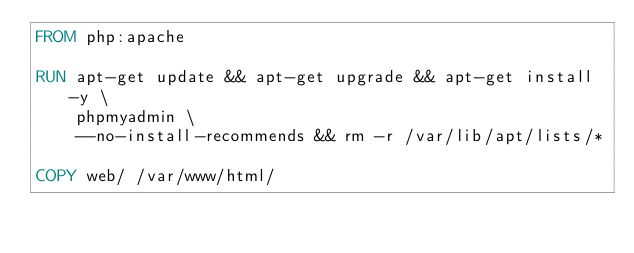<code> <loc_0><loc_0><loc_500><loc_500><_Dockerfile_>FROM php:apache

RUN apt-get update && apt-get upgrade && apt-get install -y \
	phpmyadmin \
	--no-install-recommends && rm -r /var/lib/apt/lists/*

COPY web/ /var/www/html/
</code> 